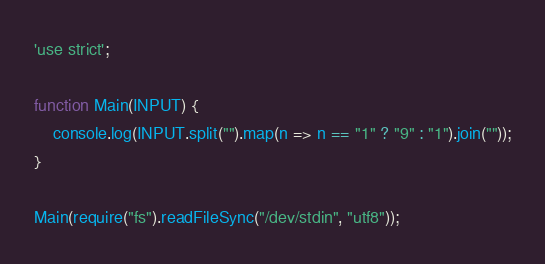<code> <loc_0><loc_0><loc_500><loc_500><_JavaScript_>'use strict';

function Main(INPUT) {
    console.log(INPUT.split("").map(n => n == "1" ? "9" : "1").join(""));
}

Main(require("fs").readFileSync("/dev/stdin", "utf8"));
</code> 